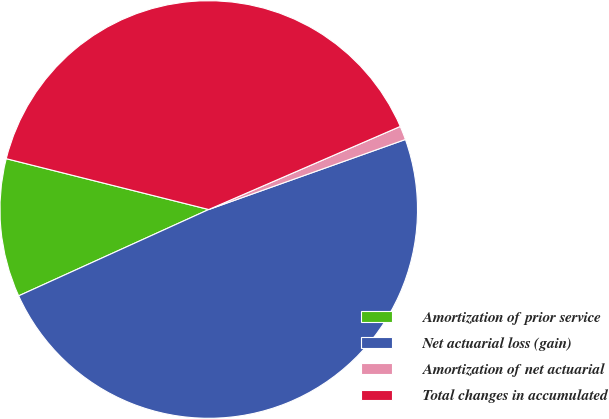Convert chart to OTSL. <chart><loc_0><loc_0><loc_500><loc_500><pie_chart><fcel>Amortization of prior service<fcel>Net actuarial loss (gain)<fcel>Amortization of net actuarial<fcel>Total changes in accumulated<nl><fcel>10.7%<fcel>48.66%<fcel>1.07%<fcel>39.57%<nl></chart> 